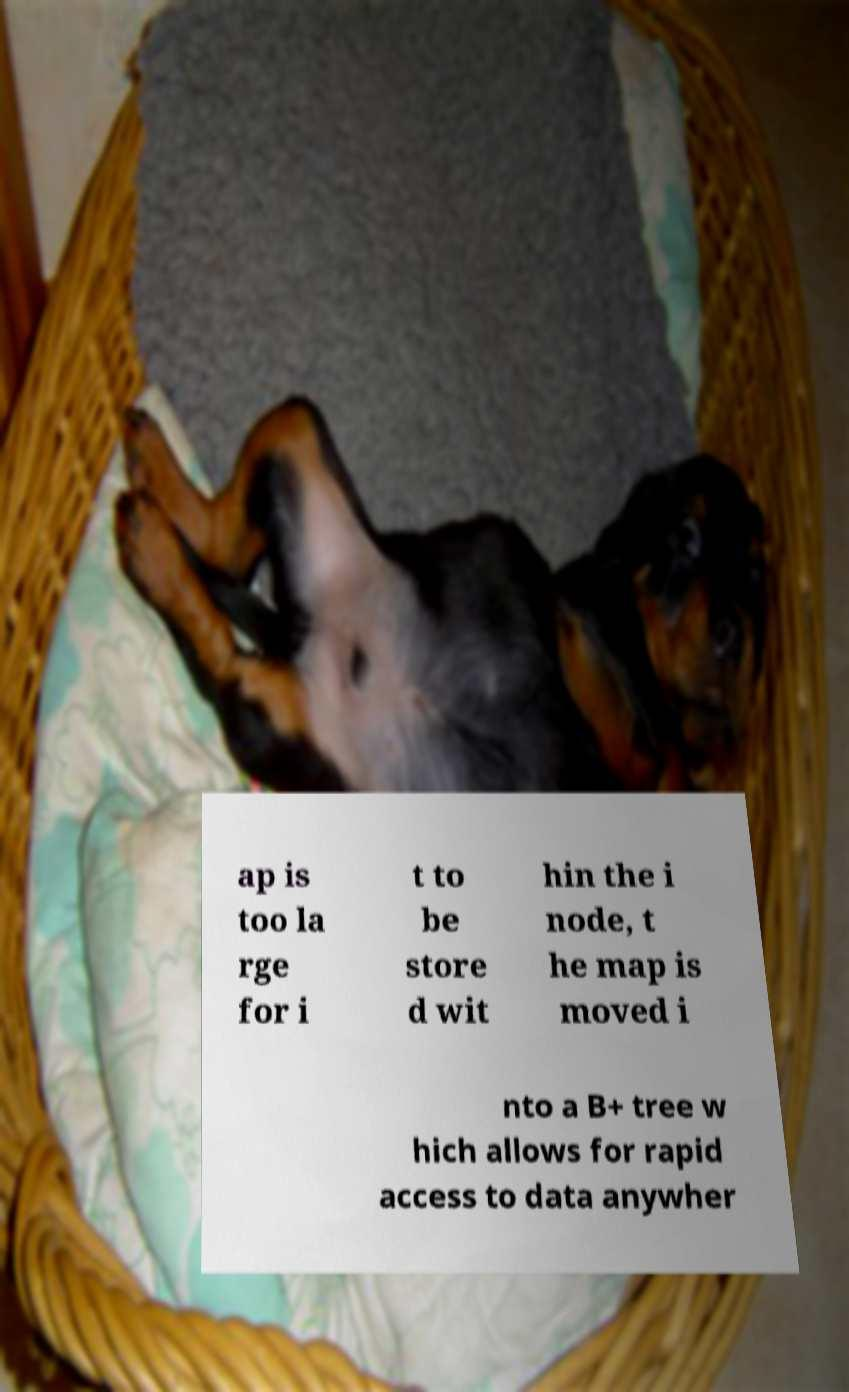What messages or text are displayed in this image? I need them in a readable, typed format. ap is too la rge for i t to be store d wit hin the i node, t he map is moved i nto a B+ tree w hich allows for rapid access to data anywher 